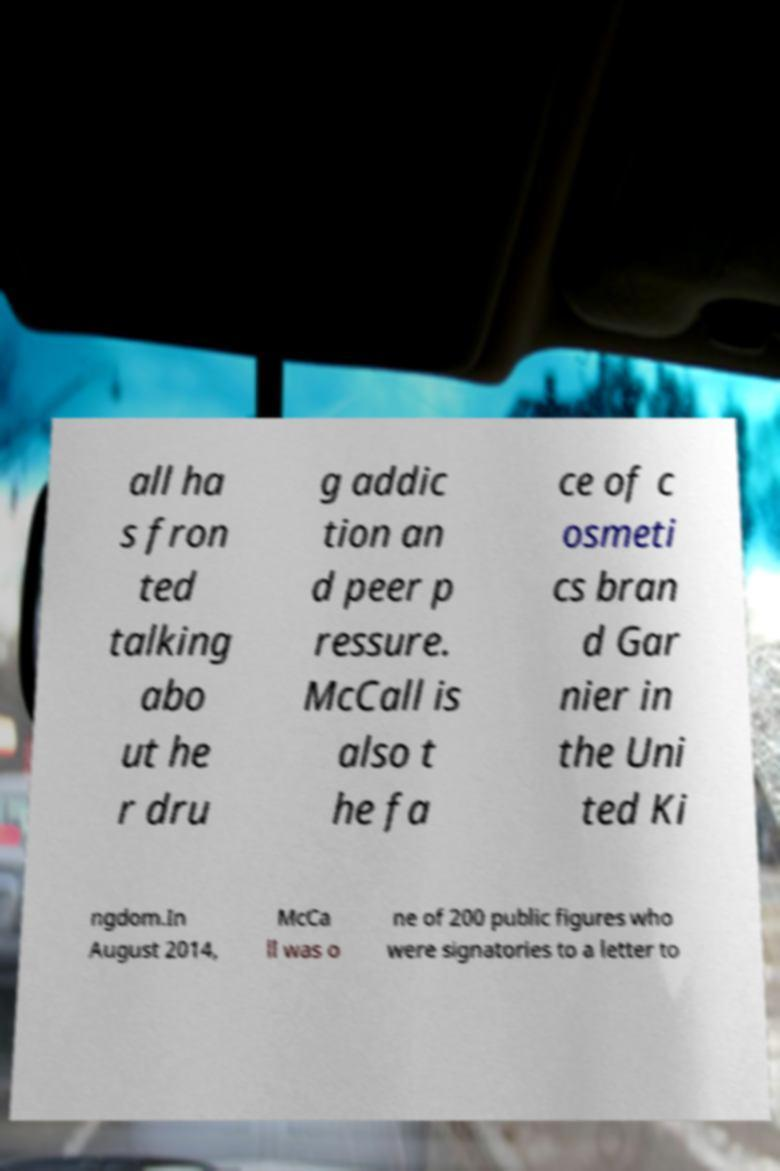Please read and relay the text visible in this image. What does it say? all ha s fron ted talking abo ut he r dru g addic tion an d peer p ressure. McCall is also t he fa ce of c osmeti cs bran d Gar nier in the Uni ted Ki ngdom.In August 2014, McCa ll was o ne of 200 public figures who were signatories to a letter to 